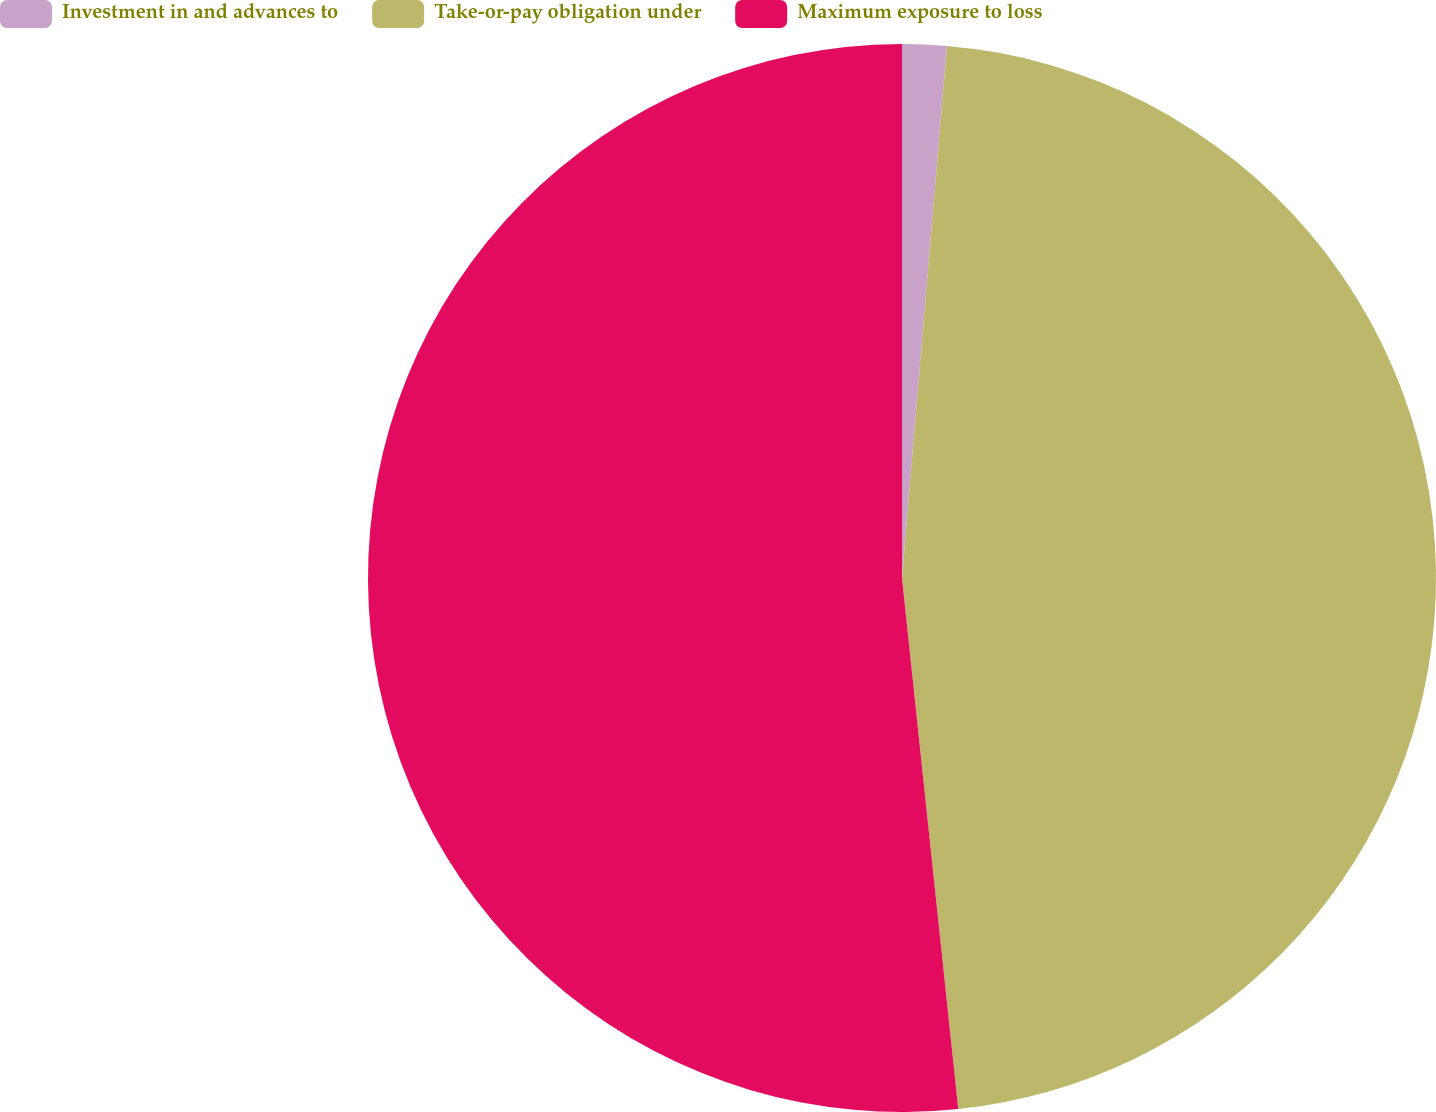<chart> <loc_0><loc_0><loc_500><loc_500><pie_chart><fcel>Investment in and advances to<fcel>Take-or-pay obligation under<fcel>Maximum exposure to loss<nl><fcel>1.34%<fcel>46.98%<fcel>51.68%<nl></chart> 